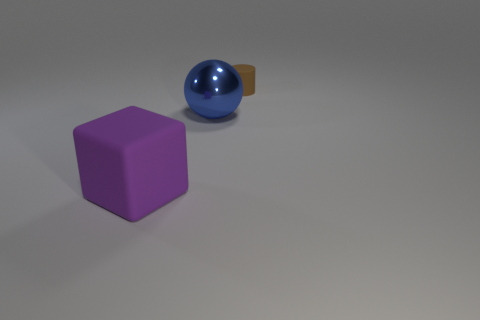Does the large purple cube have the same material as the large object that is behind the big rubber object? No, the large purple cube has a matte finish indicating it is not made of the same glossy material as the large sphere behind the big rubber object, which has a reflective surface. 